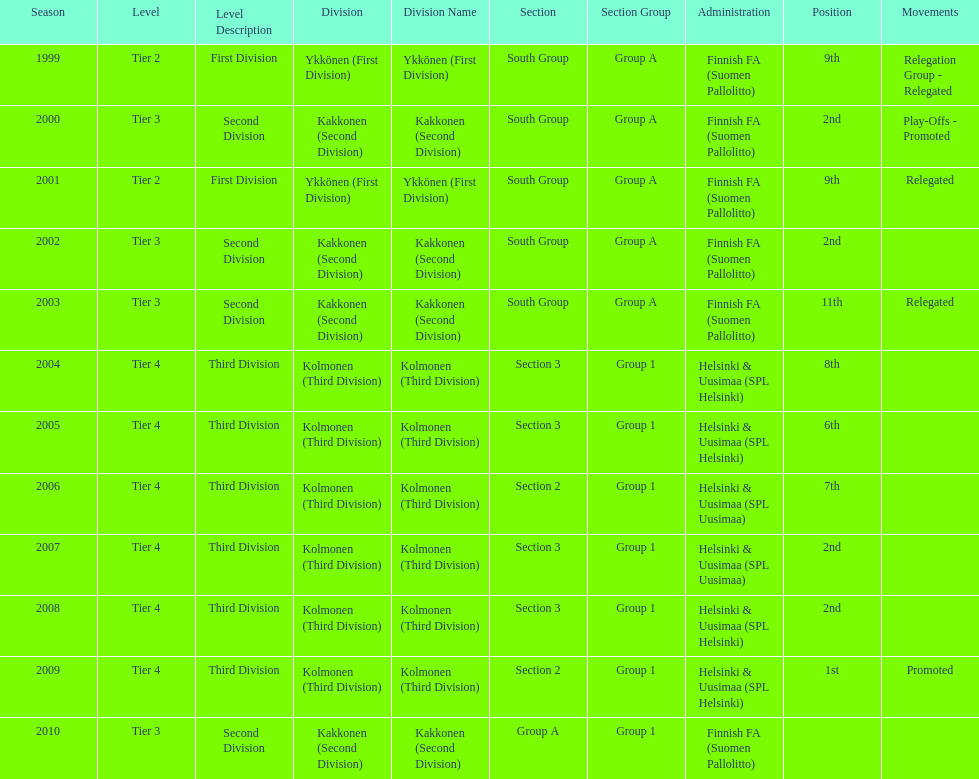How many 2nd positions were there? 4. Parse the table in full. {'header': ['Season', 'Level', 'Level Description', 'Division', 'Division Name', 'Section', 'Section Group', 'Administration', 'Position', 'Movements'], 'rows': [['1999', 'Tier 2', 'First Division', 'Ykkönen (First Division)', 'Ykkönen (First Division)', 'South Group', 'Group A', 'Finnish FA (Suomen Pallolitto)', '9th', 'Relegation Group - Relegated'], ['2000', 'Tier 3', 'Second Division', 'Kakkonen (Second Division)', 'Kakkonen (Second Division)', 'South Group', 'Group A', 'Finnish FA (Suomen Pallolitto)', '2nd', 'Play-Offs - Promoted'], ['2001', 'Tier 2', 'First Division', 'Ykkönen (First Division)', 'Ykkönen (First Division)', 'South Group', 'Group A', 'Finnish FA (Suomen Pallolitto)', '9th', 'Relegated'], ['2002', 'Tier 3', 'Second Division', 'Kakkonen (Second Division)', 'Kakkonen (Second Division)', 'South Group', 'Group A', 'Finnish FA (Suomen Pallolitto)', '2nd', ''], ['2003', 'Tier 3', 'Second Division', 'Kakkonen (Second Division)', 'Kakkonen (Second Division)', 'South Group', 'Group A', 'Finnish FA (Suomen Pallolitto)', '11th', 'Relegated'], ['2004', 'Tier 4', 'Third Division', 'Kolmonen (Third Division)', 'Kolmonen (Third Division)', 'Section 3', 'Group 1', 'Helsinki & Uusimaa (SPL Helsinki)', '8th', ''], ['2005', 'Tier 4', 'Third Division', 'Kolmonen (Third Division)', 'Kolmonen (Third Division)', 'Section 3', 'Group 1', 'Helsinki & Uusimaa (SPL Helsinki)', '6th', ''], ['2006', 'Tier 4', 'Third Division', 'Kolmonen (Third Division)', 'Kolmonen (Third Division)', 'Section 2', 'Group 1', 'Helsinki & Uusimaa (SPL Uusimaa)', '7th', ''], ['2007', 'Tier 4', 'Third Division', 'Kolmonen (Third Division)', 'Kolmonen (Third Division)', 'Section 3', 'Group 1', 'Helsinki & Uusimaa (SPL Uusimaa)', '2nd', ''], ['2008', 'Tier 4', 'Third Division', 'Kolmonen (Third Division)', 'Kolmonen (Third Division)', 'Section 3', 'Group 1', 'Helsinki & Uusimaa (SPL Helsinki)', '2nd', ''], ['2009', 'Tier 4', 'Third Division', 'Kolmonen (Third Division)', 'Kolmonen (Third Division)', 'Section 2', 'Group 1', 'Helsinki & Uusimaa (SPL Helsinki)', '1st', 'Promoted'], ['2010', 'Tier 3', 'Second Division', 'Kakkonen (Second Division)', 'Kakkonen (Second Division)', 'Group A', 'Group 1', 'Finnish FA (Suomen Pallolitto)', '', '']]} 